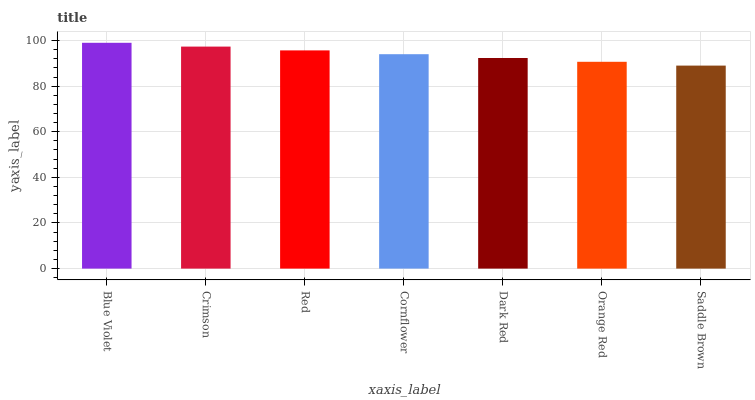Is Saddle Brown the minimum?
Answer yes or no. Yes. Is Blue Violet the maximum?
Answer yes or no. Yes. Is Crimson the minimum?
Answer yes or no. No. Is Crimson the maximum?
Answer yes or no. No. Is Blue Violet greater than Crimson?
Answer yes or no. Yes. Is Crimson less than Blue Violet?
Answer yes or no. Yes. Is Crimson greater than Blue Violet?
Answer yes or no. No. Is Blue Violet less than Crimson?
Answer yes or no. No. Is Cornflower the high median?
Answer yes or no. Yes. Is Cornflower the low median?
Answer yes or no. Yes. Is Blue Violet the high median?
Answer yes or no. No. Is Red the low median?
Answer yes or no. No. 